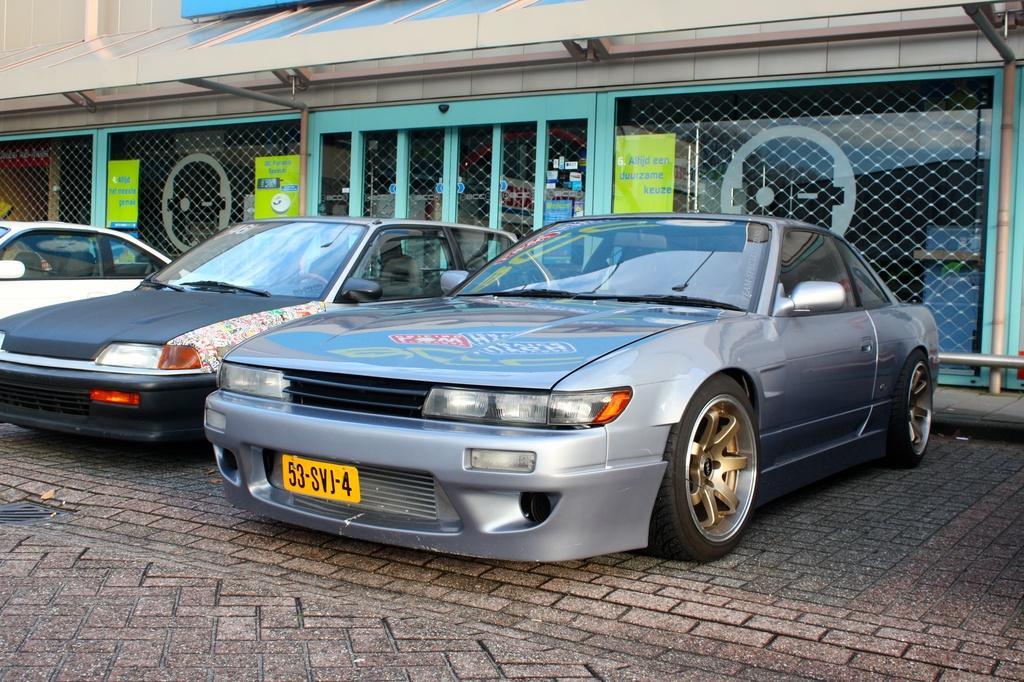Can you describe this image briefly? In this image I can see three cars on the road. In the background I can see a building, boards, fence, metal rods and wall. This image is taken may be during a day. 